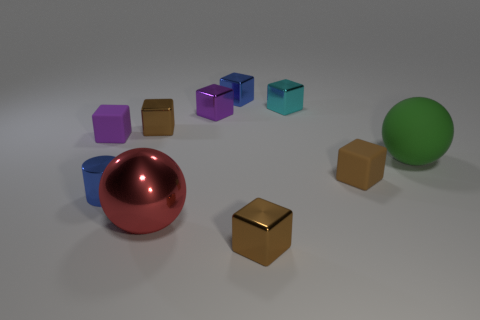Subtract all blue cylinders. How many brown blocks are left? 3 Subtract all brown blocks. How many blocks are left? 4 Subtract all small blue shiny blocks. How many blocks are left? 6 Subtract all yellow blocks. Subtract all cyan cylinders. How many blocks are left? 7 Subtract all balls. How many objects are left? 8 Add 1 tiny blue metal balls. How many tiny blue metal balls exist? 1 Subtract 0 cyan cylinders. How many objects are left? 10 Subtract all tiny blue cylinders. Subtract all big shiny things. How many objects are left? 8 Add 4 brown cubes. How many brown cubes are left? 7 